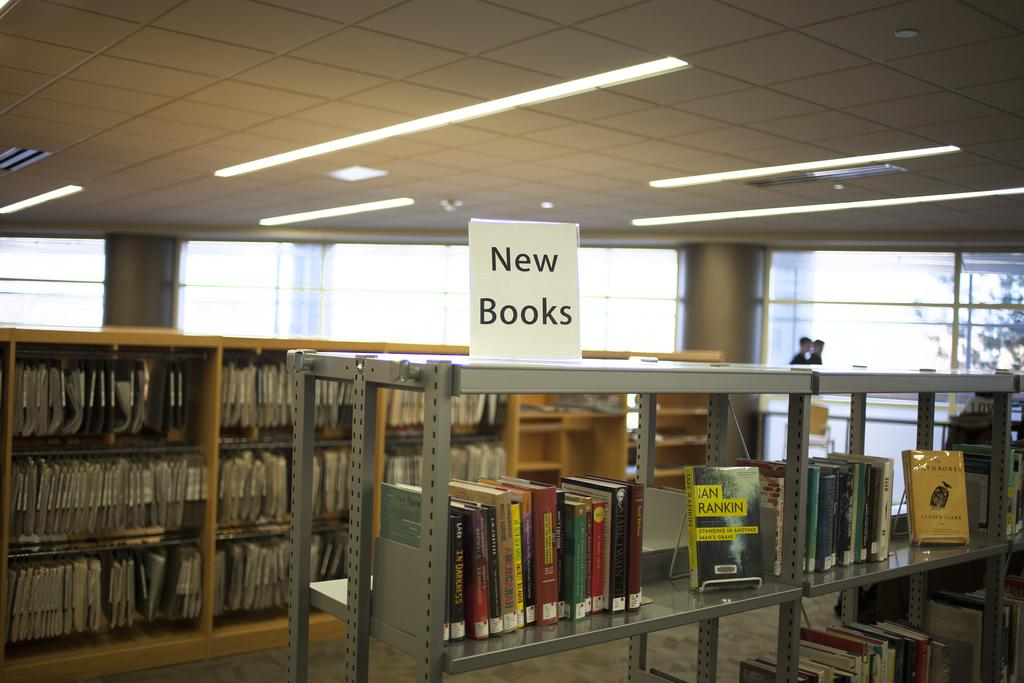<image>
Share a concise interpretation of the image provided. a library with a sign on top of a shelf that says New Books 